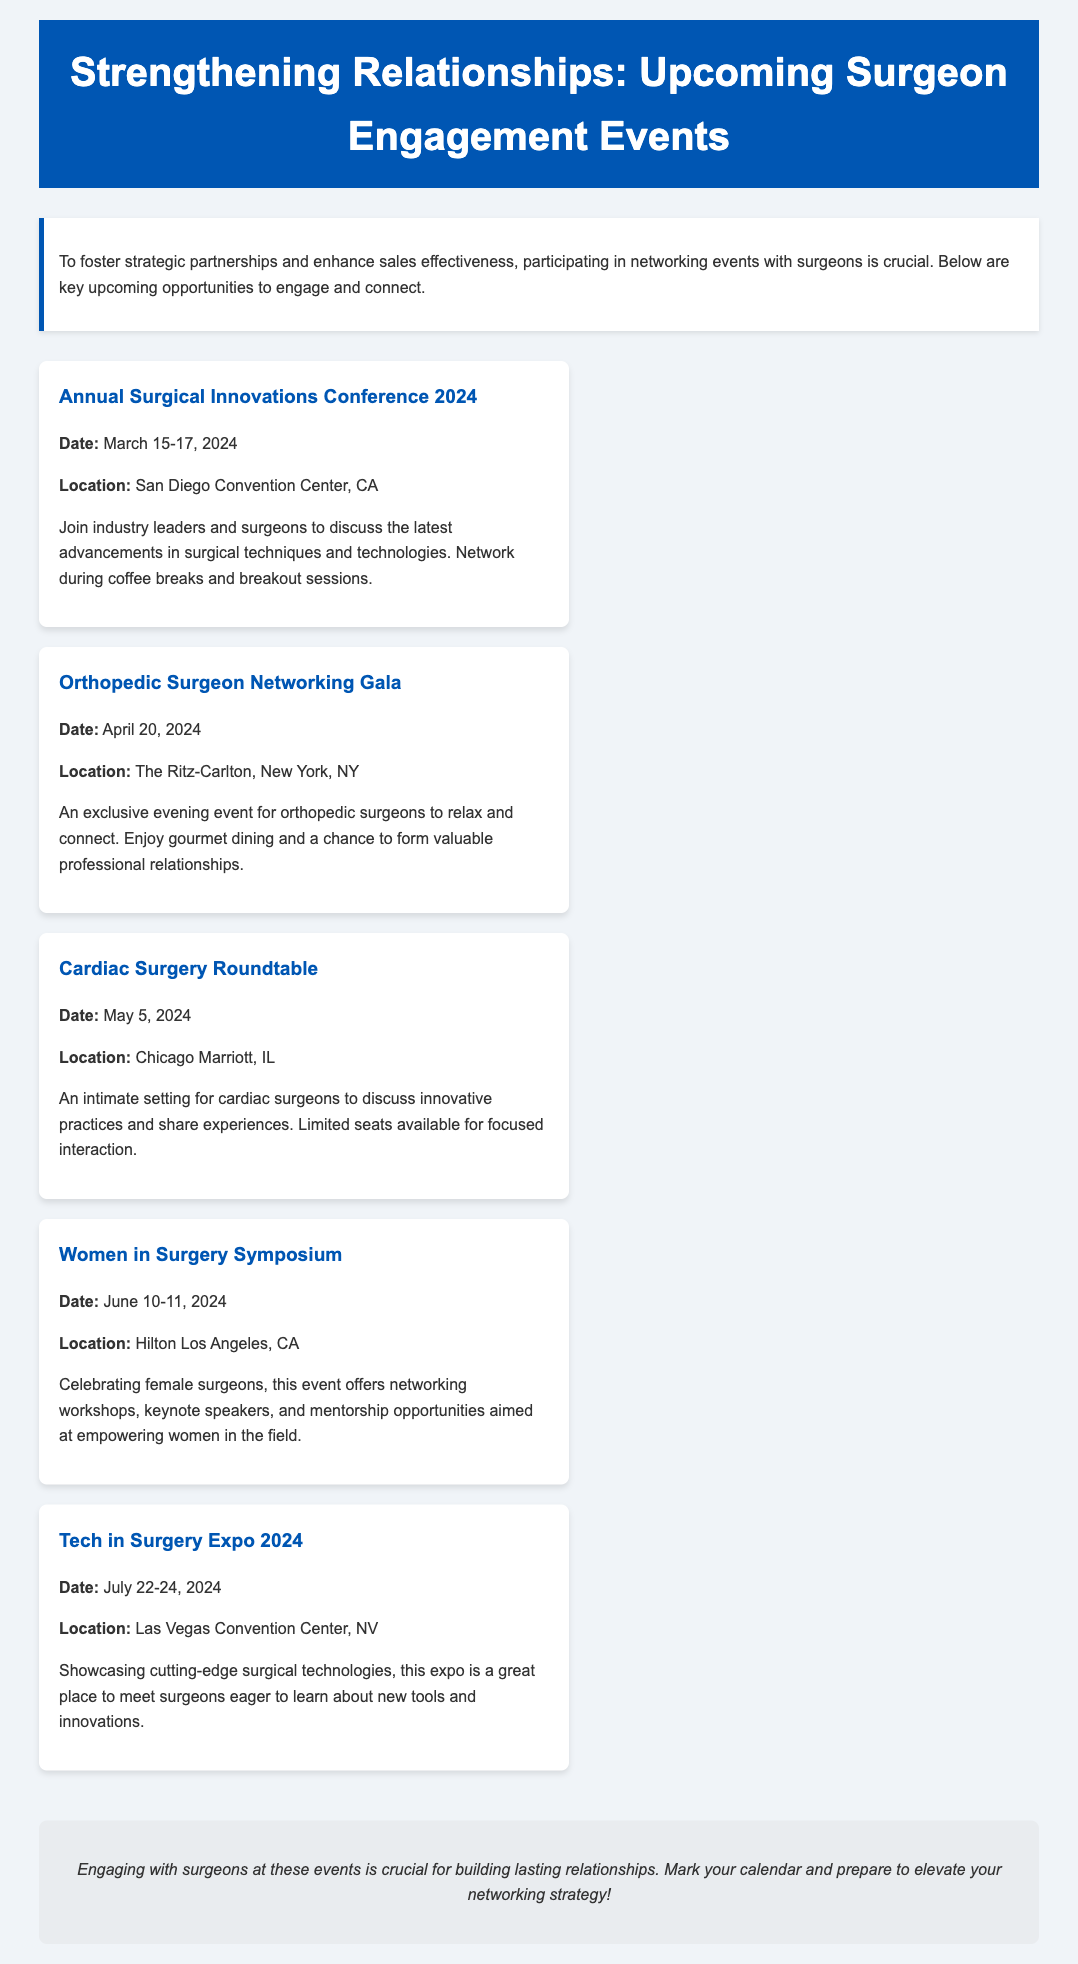what is the date of the Annual Surgical Innovations Conference 2024? The date is specifically mentioned as March 15-17, 2024.
Answer: March 15-17, 2024 where is the Orthopedic Surgeon Networking Gala being held? The location is explicitly listed as The Ritz-Carlton, New York, NY.
Answer: The Ritz-Carlton, New York, NY how many days does the Women in Surgery Symposium last? The document states that this event lasts for two days, specifically June 10-11, 2024.
Answer: Two days what topic will be discussed at the Cardiac Surgery Roundtable? The event focuses on innovative practices and sharing experiences among cardiac surgeons.
Answer: Innovative practices which event takes place in Las Vegas? The document states that the Tech in Surgery Expo 2024 is held in Las Vegas.
Answer: Tech in Surgery Expo 2024 